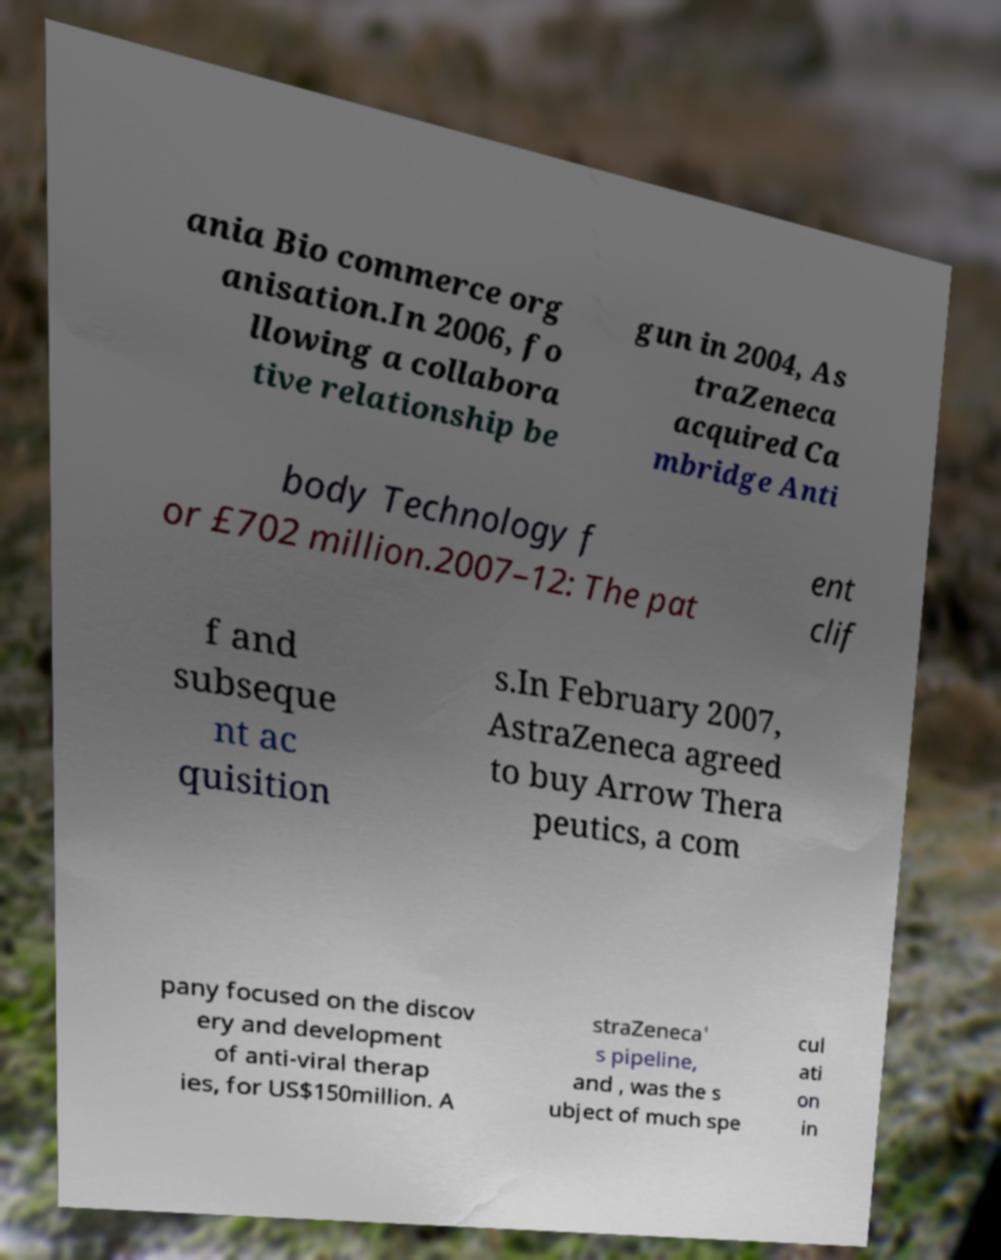Can you read and provide the text displayed in the image?This photo seems to have some interesting text. Can you extract and type it out for me? ania Bio commerce org anisation.In 2006, fo llowing a collabora tive relationship be gun in 2004, As traZeneca acquired Ca mbridge Anti body Technology f or £702 million.2007–12: The pat ent clif f and subseque nt ac quisition s.In February 2007, AstraZeneca agreed to buy Arrow Thera peutics, a com pany focused on the discov ery and development of anti-viral therap ies, for US$150million. A straZeneca' s pipeline, and , was the s ubject of much spe cul ati on in 